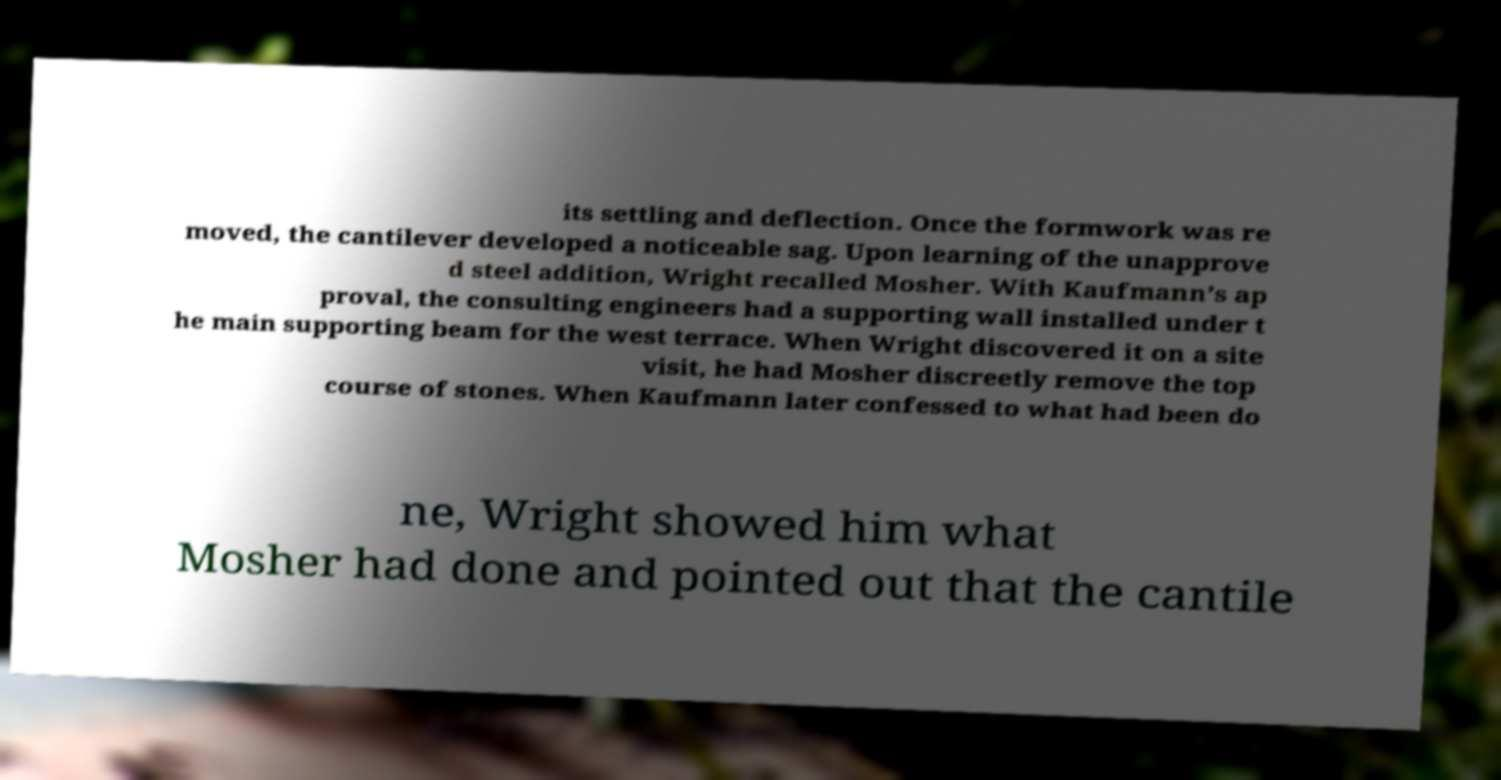Please identify and transcribe the text found in this image. its settling and deflection. Once the formwork was re moved, the cantilever developed a noticeable sag. Upon learning of the unapprove d steel addition, Wright recalled Mosher. With Kaufmann’s ap proval, the consulting engineers had a supporting wall installed under t he main supporting beam for the west terrace. When Wright discovered it on a site visit, he had Mosher discreetly remove the top course of stones. When Kaufmann later confessed to what had been do ne, Wright showed him what Mosher had done and pointed out that the cantile 